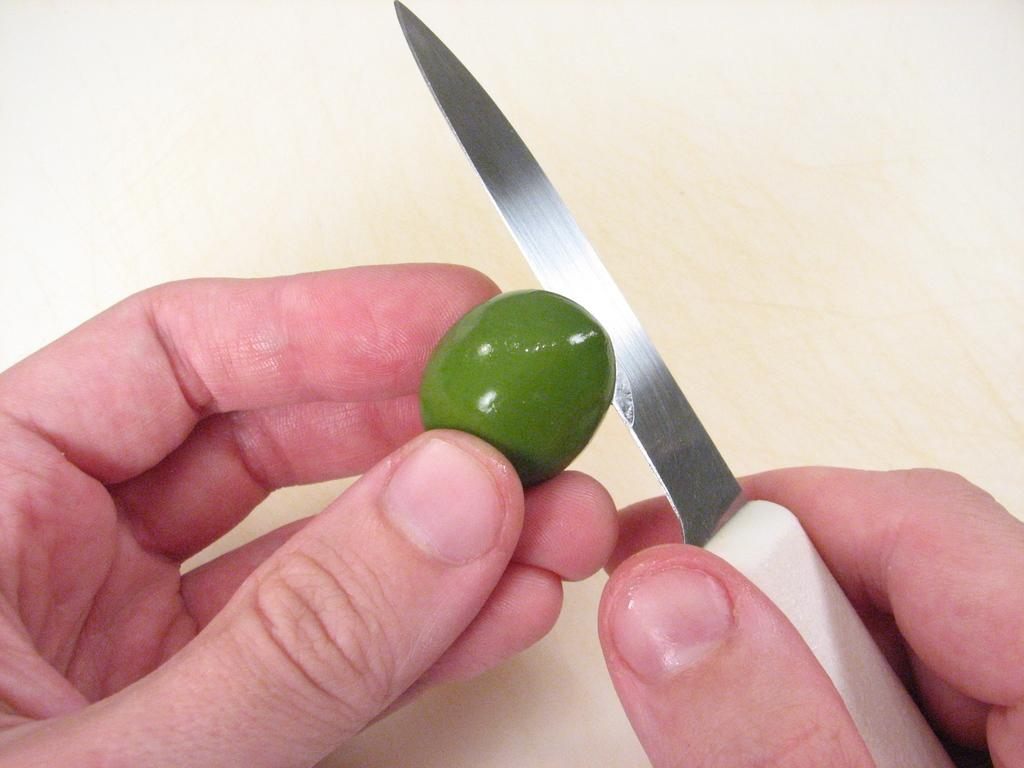What type of food item is present in the image? There is a fruit in the image. What is the person in the image holding? The person is holding a knife in the image. What type of pet can be seen in the image? There is no pet present in the image. What part of the fruit is being cut by the person holding the knife? The image does not show the person cutting the fruit, so it is not possible to determine which part of the fruit is being cut. 